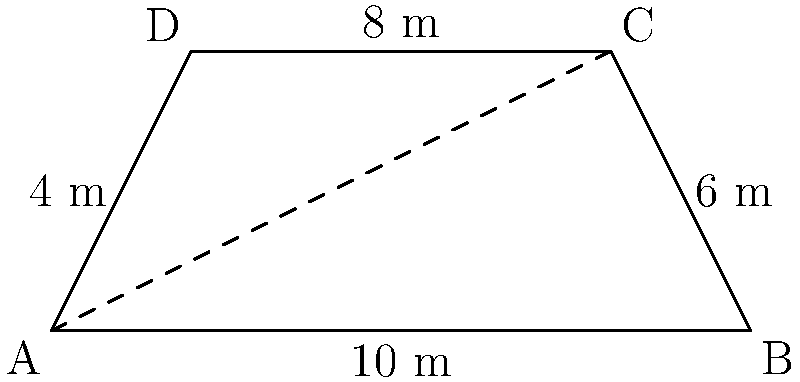For an upcoming Baccara concert, you need to calculate the area of the trapezoidal stage. The stage has the following dimensions: the parallel sides measure 8 m and 10 m, while the height (distance between parallel sides) is 4 m. What is the total area of the stage in square meters? To calculate the area of a trapezoid, we use the formula:

$$A = \frac{(a+b)h}{2}$$

Where:
$A$ = Area of the trapezoid
$a$ and $b$ = Lengths of the parallel sides
$h$ = Height (distance between parallel sides)

Given:
$a = 8$ m (top side)
$b = 10$ m (bottom side)
$h = 4$ m (height)

Let's substitute these values into the formula:

$$A = \frac{(8+10) \times 4}{2}$$

$$A = \frac{18 \times 4}{2}$$

$$A = \frac{72}{2}$$

$$A = 36$$

Therefore, the total area of the stage is 36 square meters.
Answer: 36 m² 